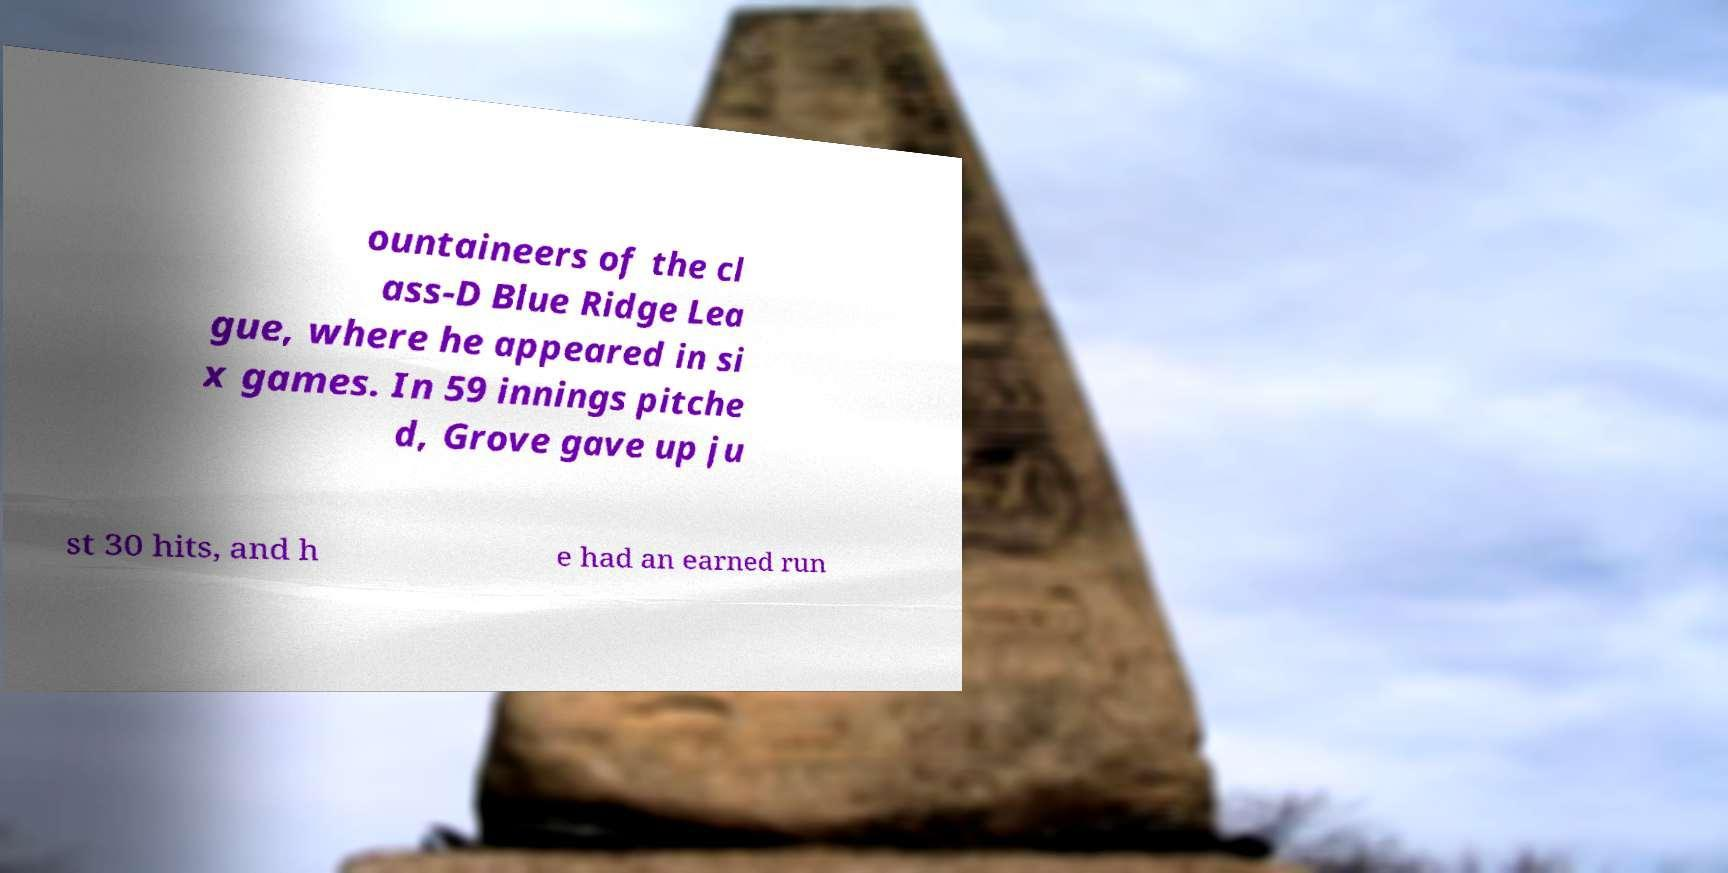What messages or text are displayed in this image? I need them in a readable, typed format. ountaineers of the cl ass-D Blue Ridge Lea gue, where he appeared in si x games. In 59 innings pitche d, Grove gave up ju st 30 hits, and h e had an earned run 